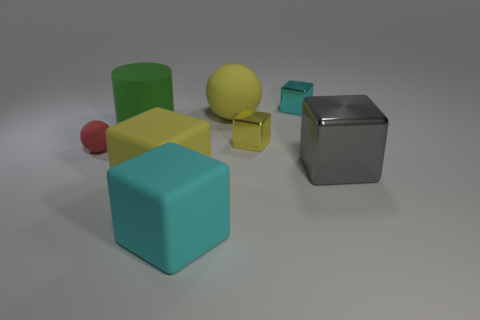How many purple things are either rubber things or spheres? 0 